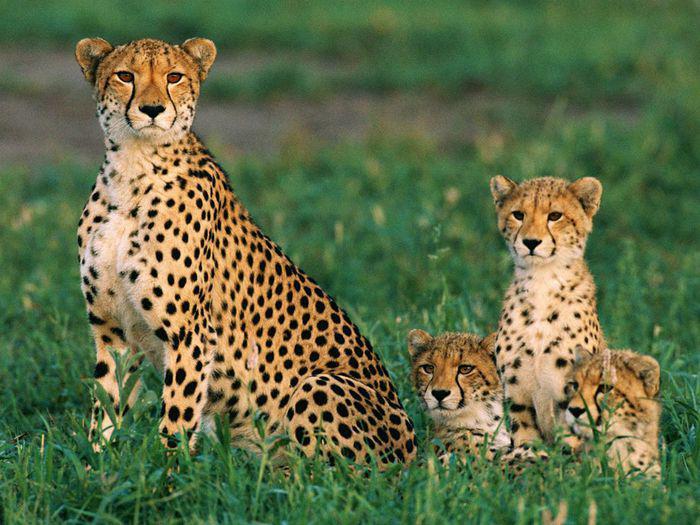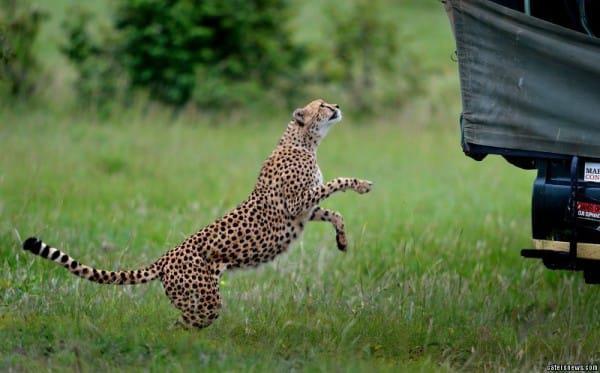The first image is the image on the left, the second image is the image on the right. Assess this claim about the two images: "The animals are running with their front legs air bound". Correct or not? Answer yes or no. No. The first image is the image on the left, the second image is the image on the right. Analyze the images presented: Is the assertion "An image shows one running cheetah with front paws off the ground." valid? Answer yes or no. No. 